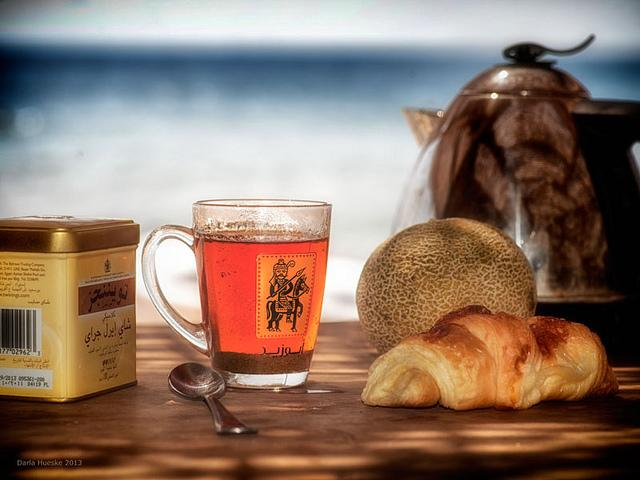What kind of beverage is there on the table top? tea 